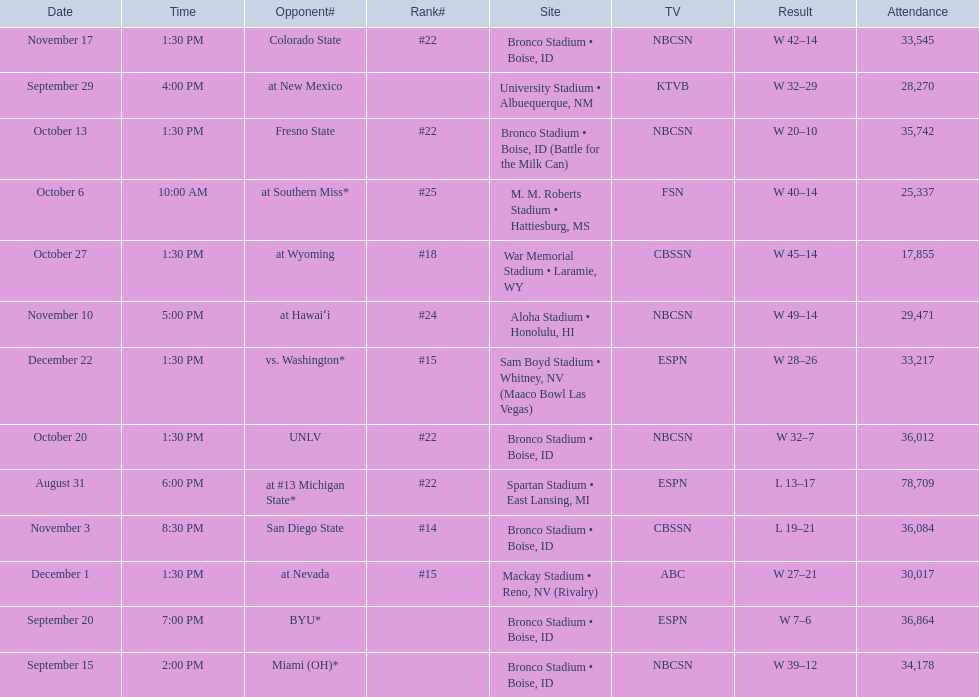What was the team's listed rankings for the season? #22, , , , #25, #22, #22, #18, #14, #24, #22, #15, #15. Which of these ranks is the best? #14. 